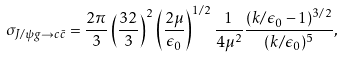Convert formula to latex. <formula><loc_0><loc_0><loc_500><loc_500>\sigma _ { J / \psi g \rightarrow c \bar { c } } = \frac { 2 \pi } { 3 } \left ( \frac { 3 2 } { 3 } \right ) ^ { 2 } \left ( \frac { 2 \mu } { \epsilon _ { 0 } } \right ) ^ { 1 / 2 } \frac { 1 } { 4 \mu ^ { 2 } } \frac { ( k / \epsilon _ { 0 } - 1 ) ^ { 3 / 2 } } { ( k / \epsilon _ { 0 } ) ^ { 5 } } ,</formula> 